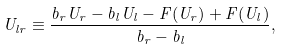<formula> <loc_0><loc_0><loc_500><loc_500>U _ { l r } \equiv \frac { b _ { r } U _ { r } - b _ { l } U _ { l } - F ( U _ { r } ) + F ( U _ { l } ) } { b _ { r } - b _ { l } } ,</formula> 